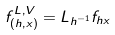<formula> <loc_0><loc_0><loc_500><loc_500>f ^ { L , V } _ { ( h , x ) } = L _ { h ^ { - 1 } } f _ { h x }</formula> 